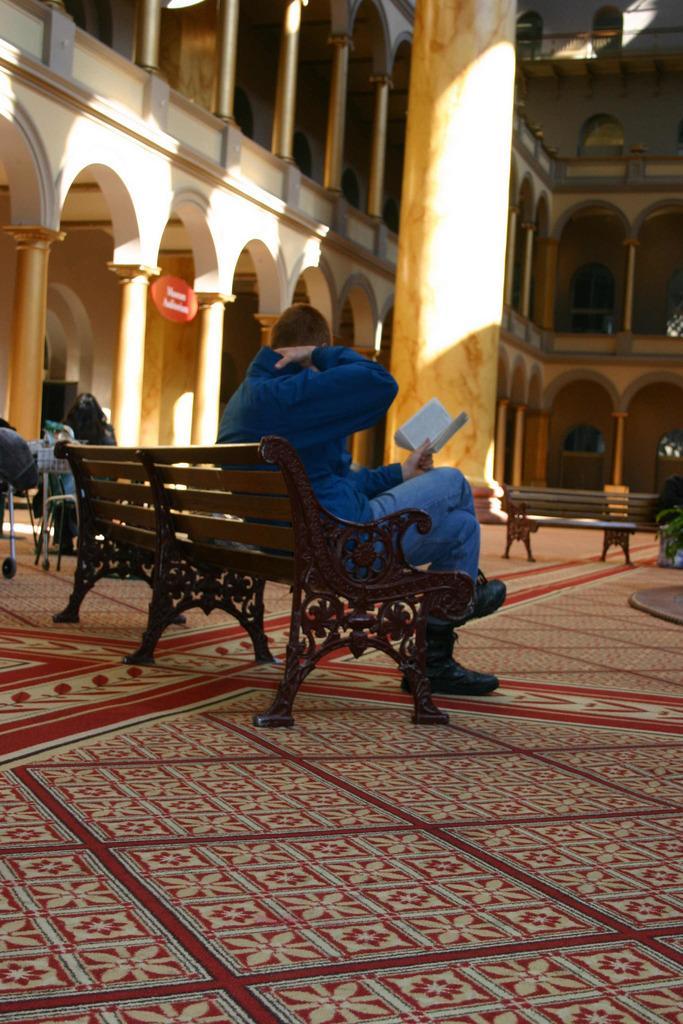Can you describe this image briefly? In the middle there is a bench on that bench a man is sitting he wear a jacket,trouser and shoes ,he is holding a book. In the middle there is a pillar. In the background there is a building. 